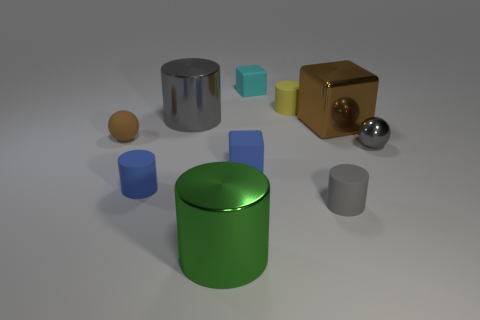Subtract 2 cylinders. How many cylinders are left? 3 Subtract all yellow matte cylinders. How many cylinders are left? 4 Subtract all yellow cylinders. How many cylinders are left? 4 Subtract all purple cylinders. Subtract all purple cubes. How many cylinders are left? 5 Subtract all cubes. How many objects are left? 7 Subtract all big purple shiny objects. Subtract all green cylinders. How many objects are left? 9 Add 1 big blocks. How many big blocks are left? 2 Add 9 purple spheres. How many purple spheres exist? 9 Subtract 1 brown blocks. How many objects are left? 9 